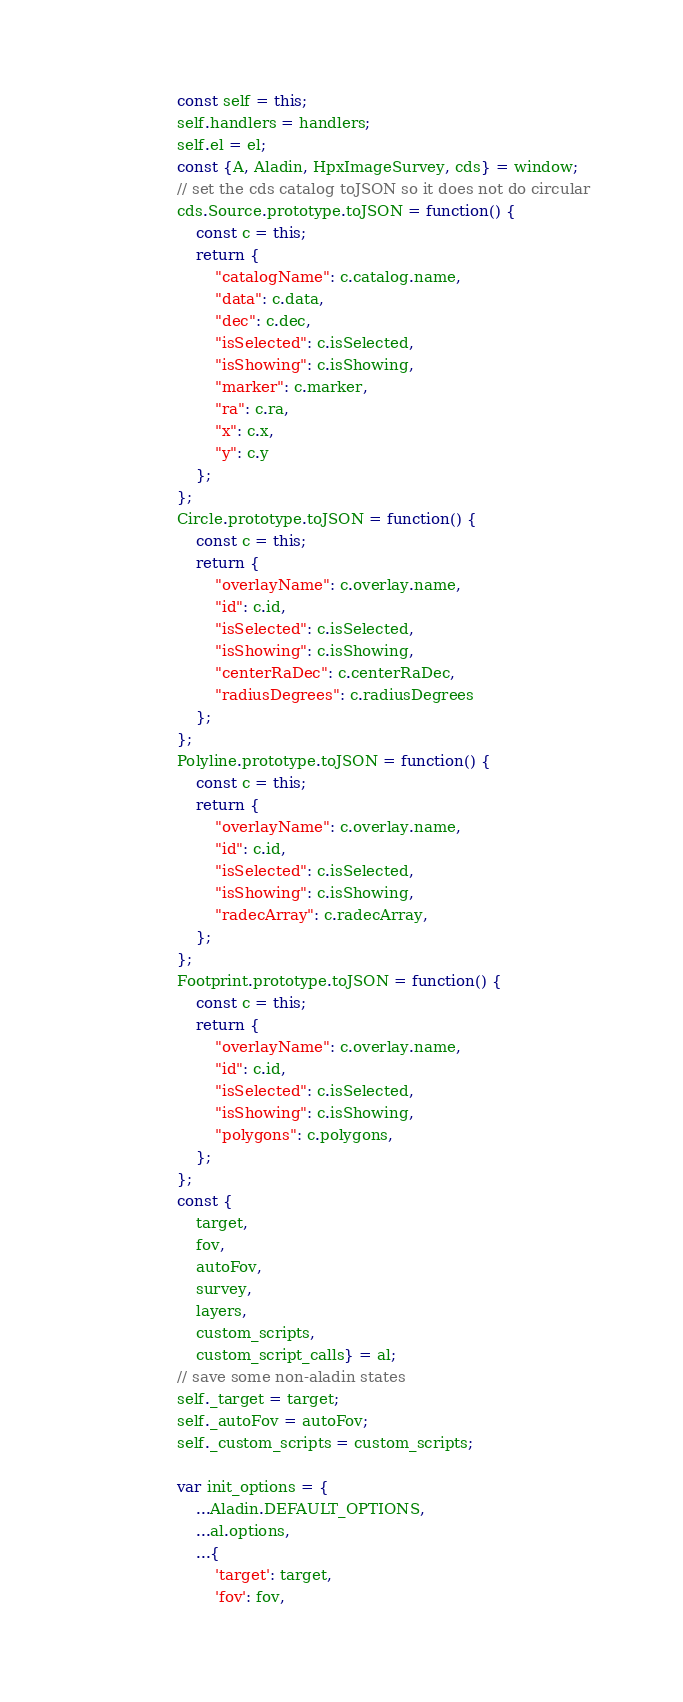<code> <loc_0><loc_0><loc_500><loc_500><_JavaScript_>        const self = this;
        self.handlers = handlers;
        self.el = el;
        const {A, Aladin, HpxImageSurvey, cds} = window;
        // set the cds catalog toJSON so it does not do circular
        cds.Source.prototype.toJSON = function() {
            const c = this;
            return {
                "catalogName": c.catalog.name,
                "data": c.data,
                "dec": c.dec,
                "isSelected": c.isSelected,
                "isShowing": c.isShowing,
                "marker": c.marker,
                "ra": c.ra,
                "x": c.x,
                "y": c.y
            };
        };
        Circle.prototype.toJSON = function() {
            const c = this;
            return {
                "overlayName": c.overlay.name,
                "id": c.id,
                "isSelected": c.isSelected,
                "isShowing": c.isShowing,
                "centerRaDec": c.centerRaDec,
                "radiusDegrees": c.radiusDegrees
            };
        };
        Polyline.prototype.toJSON = function() {
            const c = this;
            return {
                "overlayName": c.overlay.name,
                "id": c.id,
                "isSelected": c.isSelected,
                "isShowing": c.isShowing,
                "radecArray": c.radecArray,
            };
        };
        Footprint.prototype.toJSON = function() {
            const c = this;
            return {
                "overlayName": c.overlay.name,
                "id": c.id,
                "isSelected": c.isSelected,
                "isShowing": c.isShowing,
                "polygons": c.polygons,
            };
        };
        const {
            target,
            fov,
            autoFov,
            survey,
            layers,
            custom_scripts,
            custom_script_calls} = al;
        // save some non-aladin states
        self._target = target;
        self._autoFov = autoFov;
        self._custom_scripts = custom_scripts;

        var init_options = {
            ...Aladin.DEFAULT_OPTIONS,
            ...al.options,
            ...{
                'target': target,
                'fov': fov,</code> 